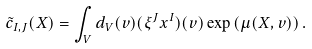<formula> <loc_0><loc_0><loc_500><loc_500>\tilde { c } _ { I , J } ( X ) = \int _ { V } d _ { V } ( v ) ( \xi ^ { J } x ^ { I } ) ( v ) \exp \left ( \mu ( X , v ) \right ) .</formula> 